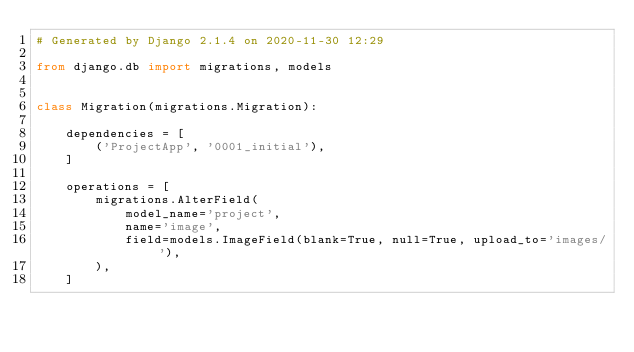<code> <loc_0><loc_0><loc_500><loc_500><_Python_># Generated by Django 2.1.4 on 2020-11-30 12:29

from django.db import migrations, models


class Migration(migrations.Migration):

    dependencies = [
        ('ProjectApp', '0001_initial'),
    ]

    operations = [
        migrations.AlterField(
            model_name='project',
            name='image',
            field=models.ImageField(blank=True, null=True, upload_to='images/'),
        ),
    ]
</code> 